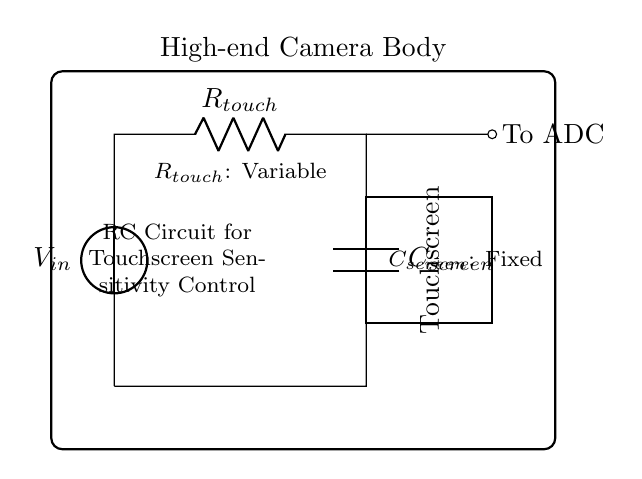What is the voltage source in this circuit? The circuit includes a voltage source labeled as \(V_{in}\), which provides the necessary voltage for the circuit.
Answer: \(V_{in}\) What does \(R_{touch}\) represent? \(R_{touch}\) is a variable resistor in this circuit that adjusts the sensitivity of the touchscreen based on the resistance value set.
Answer: Variable resistor What is the role of \(C_{screen}\)? \(C_{screen}\) is a fixed capacitor that works in conjunction with \(R_{touch}\) to control the time constant of the RC circuit, impacting the responsiveness of the touchscreen.
Answer: Fixed capacitor How does the resistance affect sensitivity? Increasing \(R_{touch}\) increases the time constant of the RC circuit, which can reduce the sensitivity of the touchscreen by resulting in slower charge and discharge times.
Answer: Increases time constant What is the overall type of the circuit? This is an RC (Resistor-Capacitor) circuit, which is utilized for controlling the charging and discharging characteristics related to the touchscreen sensitivity.
Answer: RC circuit How does the output connect to the ADC? The circuit shows that the output from the capacitor connects to the ADC (Analog-to-Digital Converter) through a short line, indicating the output signal is being processed.
Answer: To ADC 